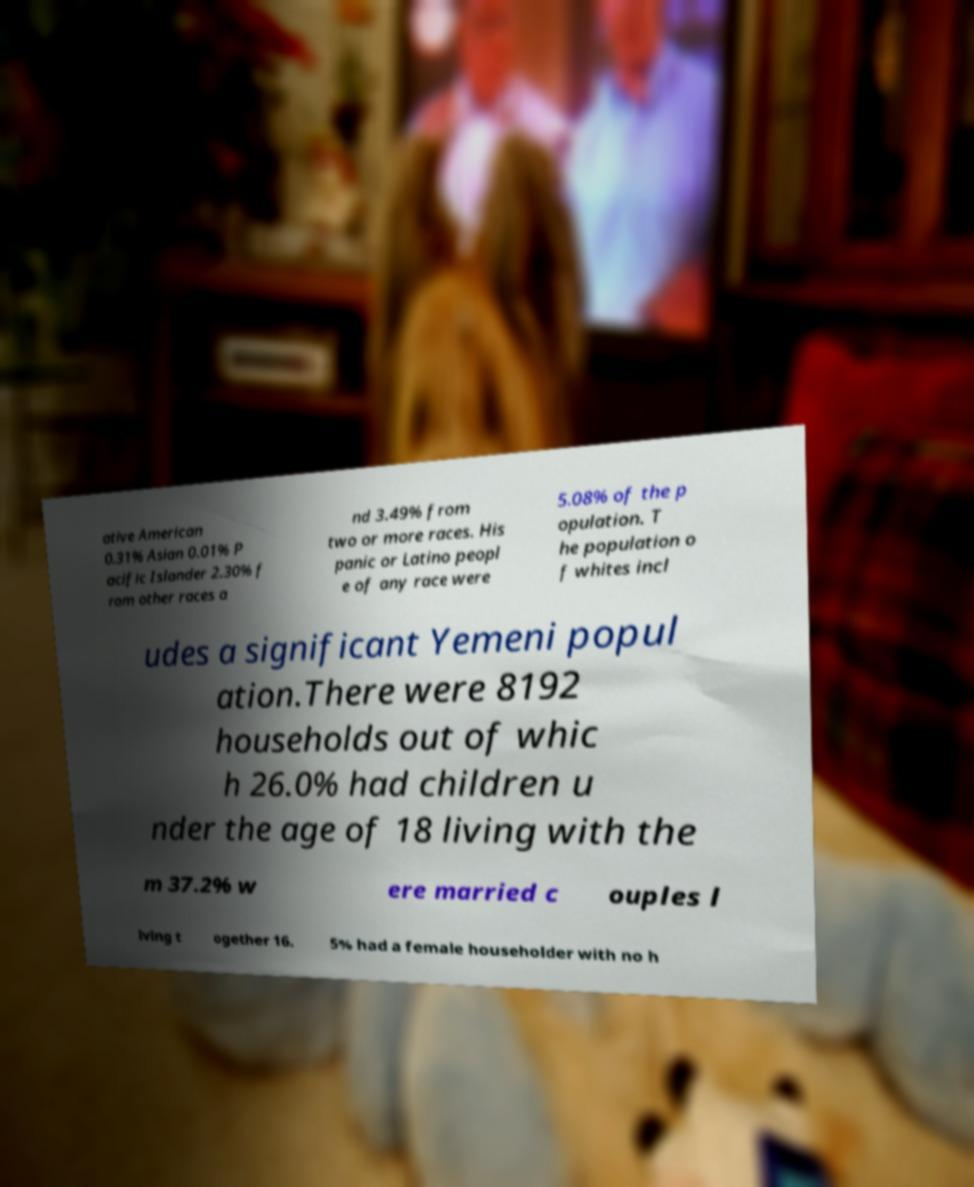What messages or text are displayed in this image? I need them in a readable, typed format. ative American 0.31% Asian 0.01% P acific Islander 2.30% f rom other races a nd 3.49% from two or more races. His panic or Latino peopl e of any race were 5.08% of the p opulation. T he population o f whites incl udes a significant Yemeni popul ation.There were 8192 households out of whic h 26.0% had children u nder the age of 18 living with the m 37.2% w ere married c ouples l iving t ogether 16. 5% had a female householder with no h 